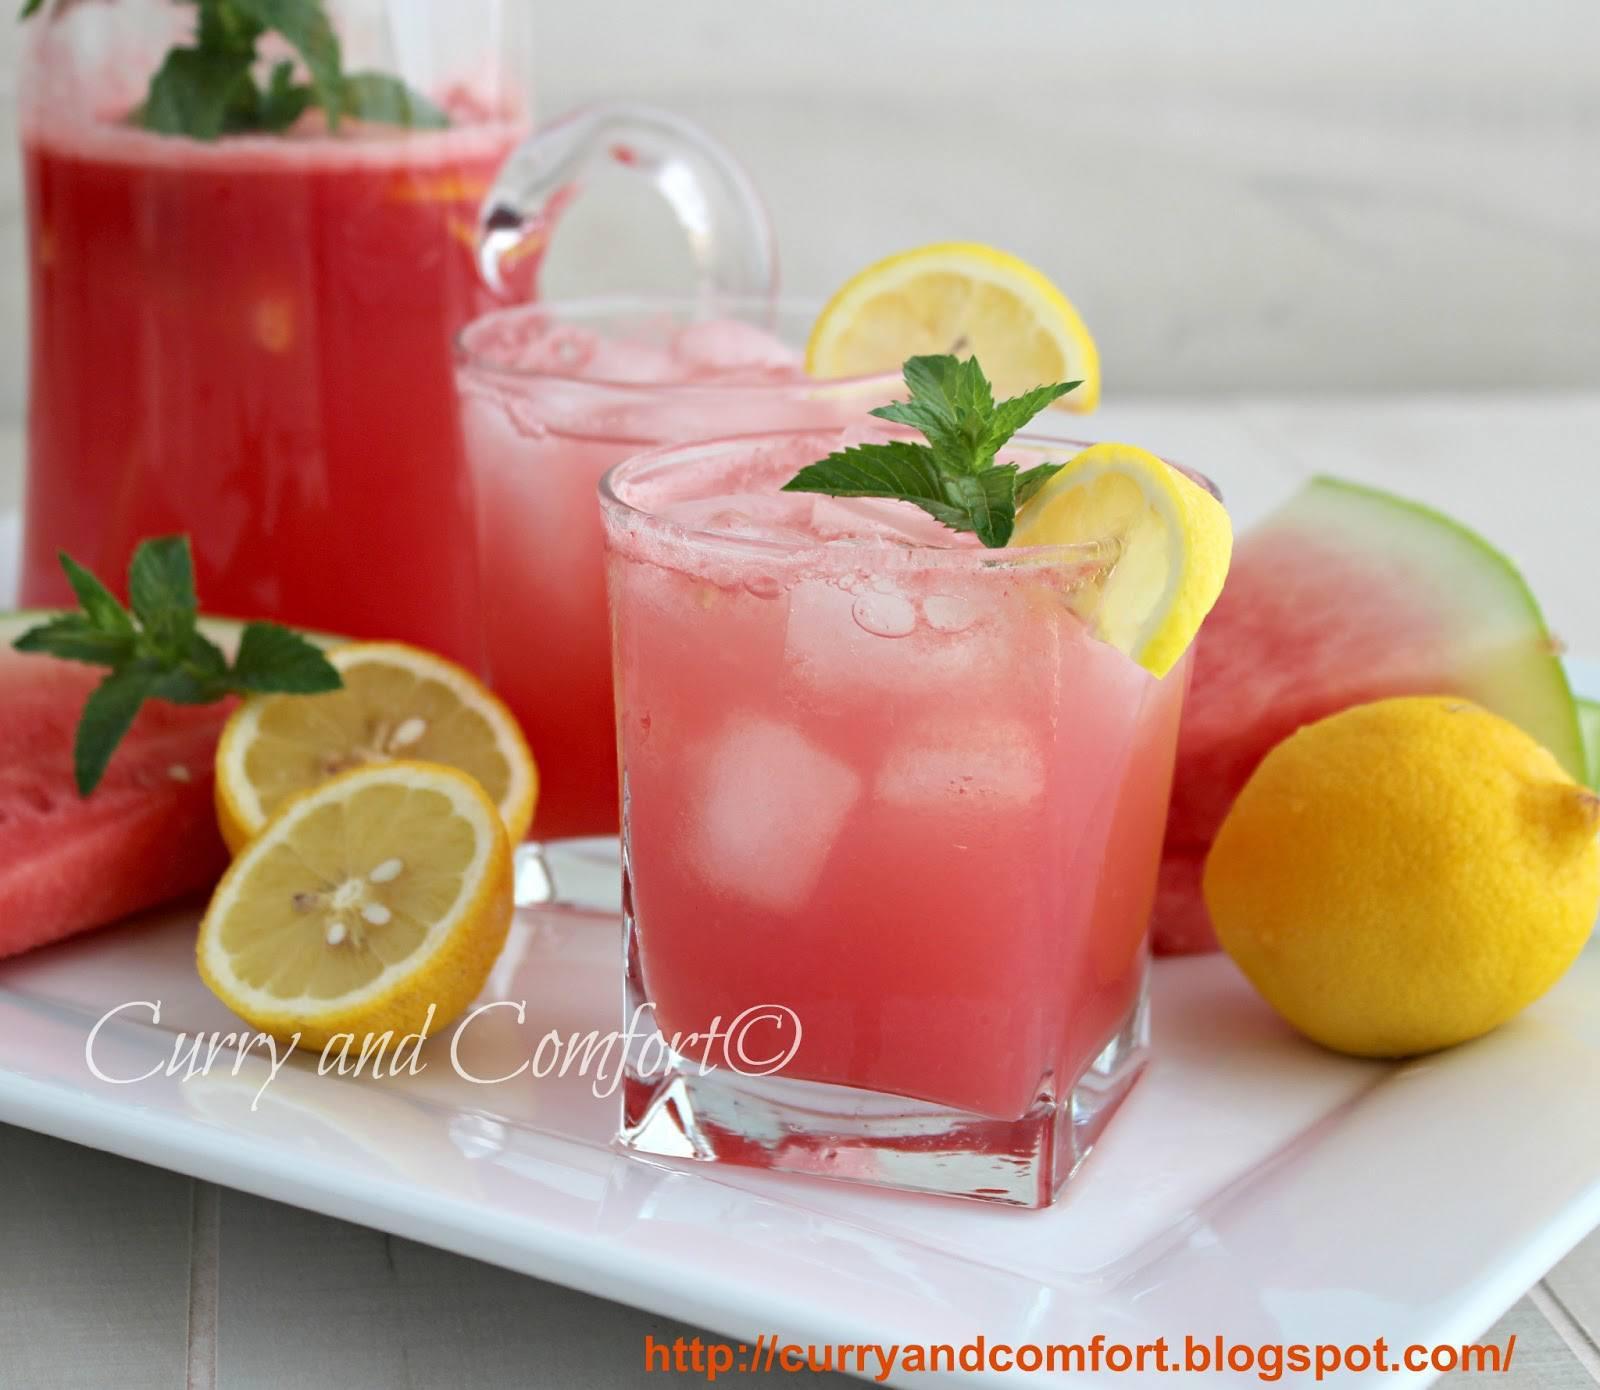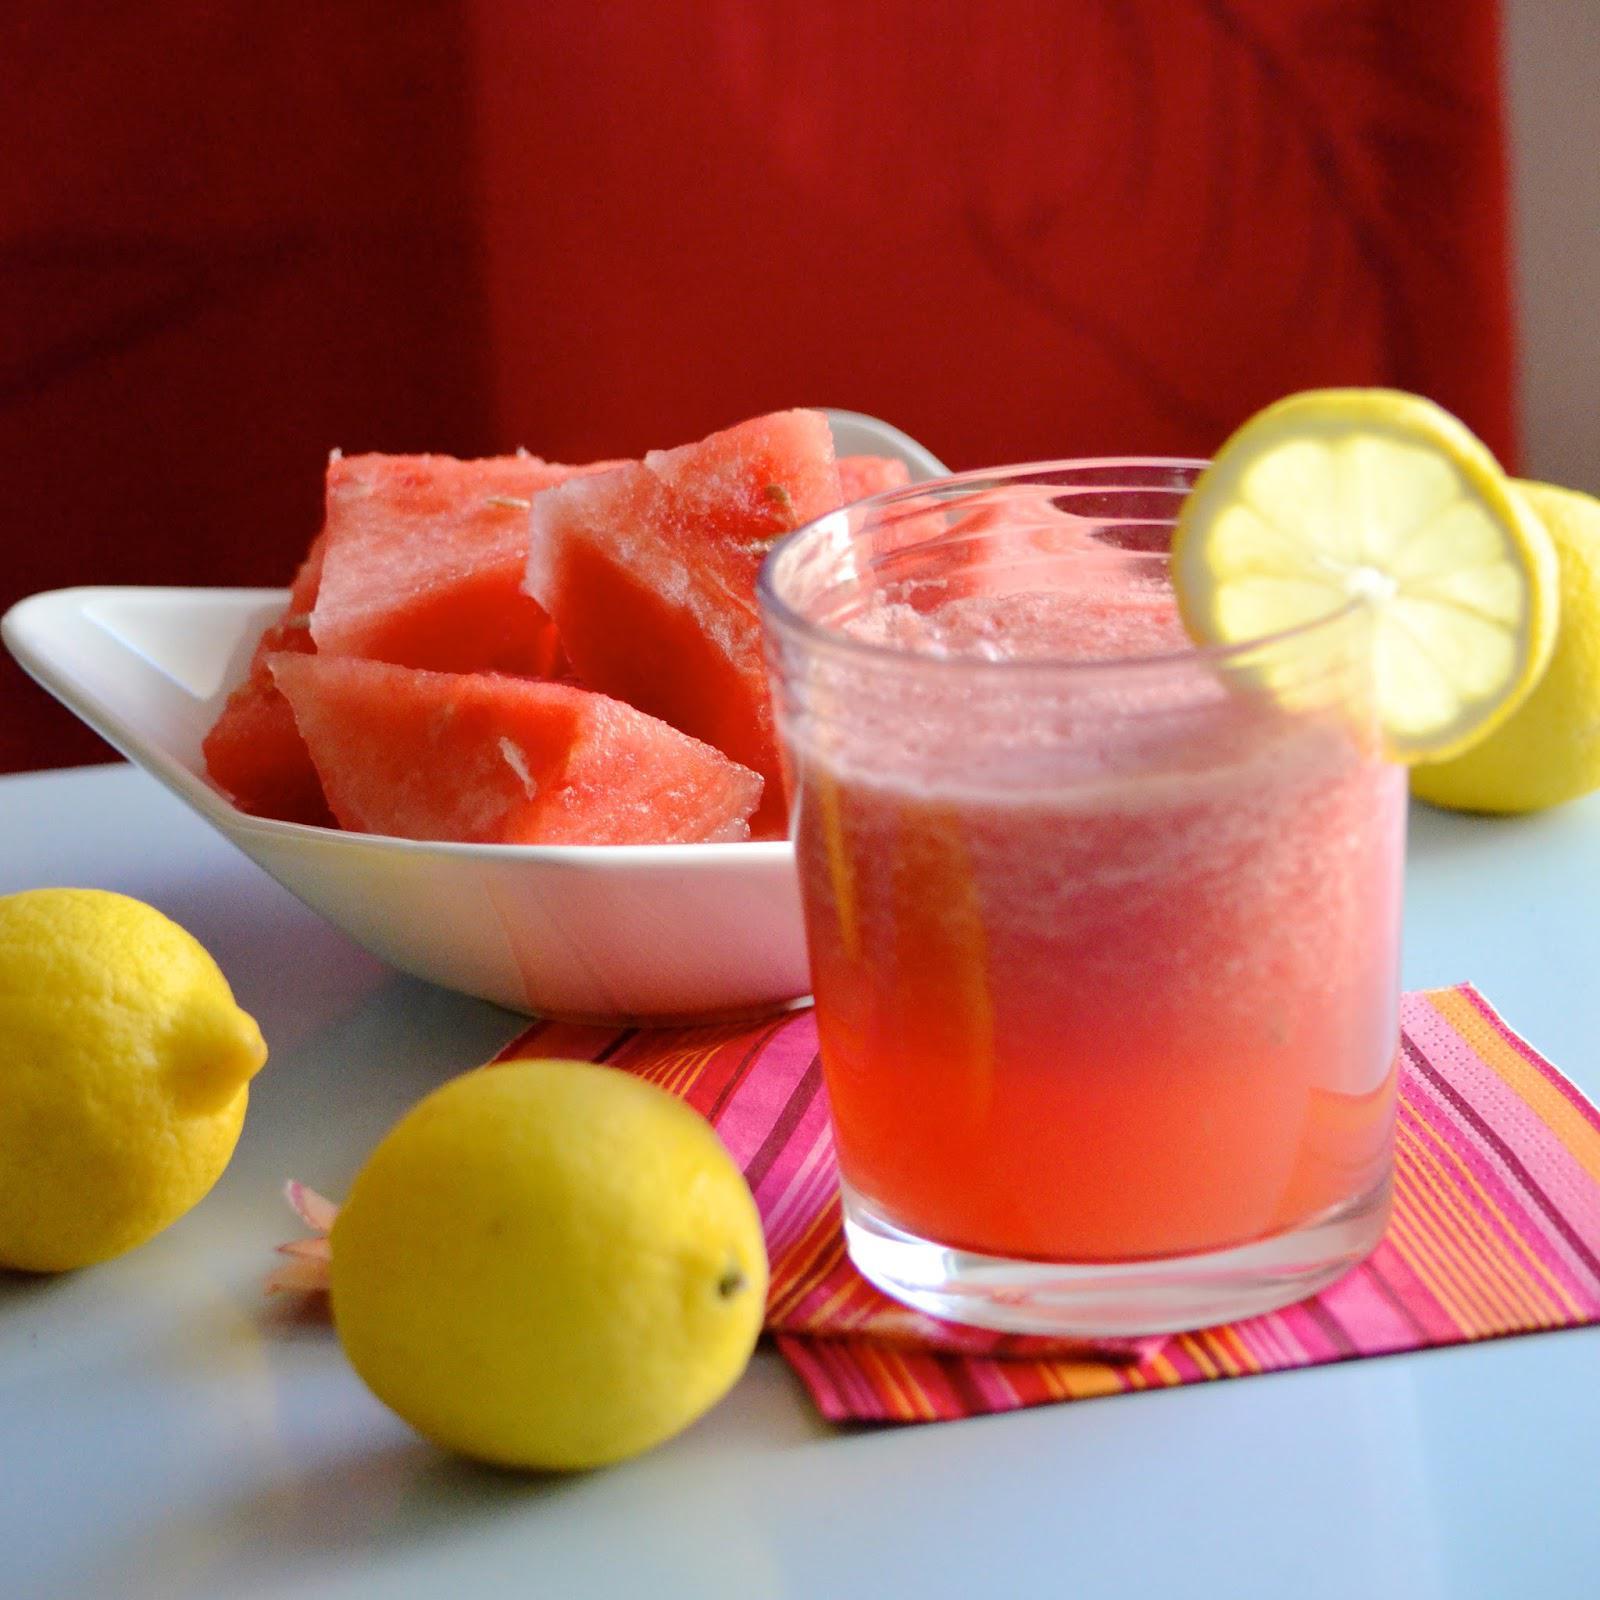The first image is the image on the left, the second image is the image on the right. For the images shown, is this caption "The liquid in the glass is pink and garnished with fruit." true? Answer yes or no. Yes. The first image is the image on the left, the second image is the image on the right. Assess this claim about the two images: "At least one small pink drink with a garnish of lemon or watermelon is seen in each image.". Correct or not? Answer yes or no. Yes. 